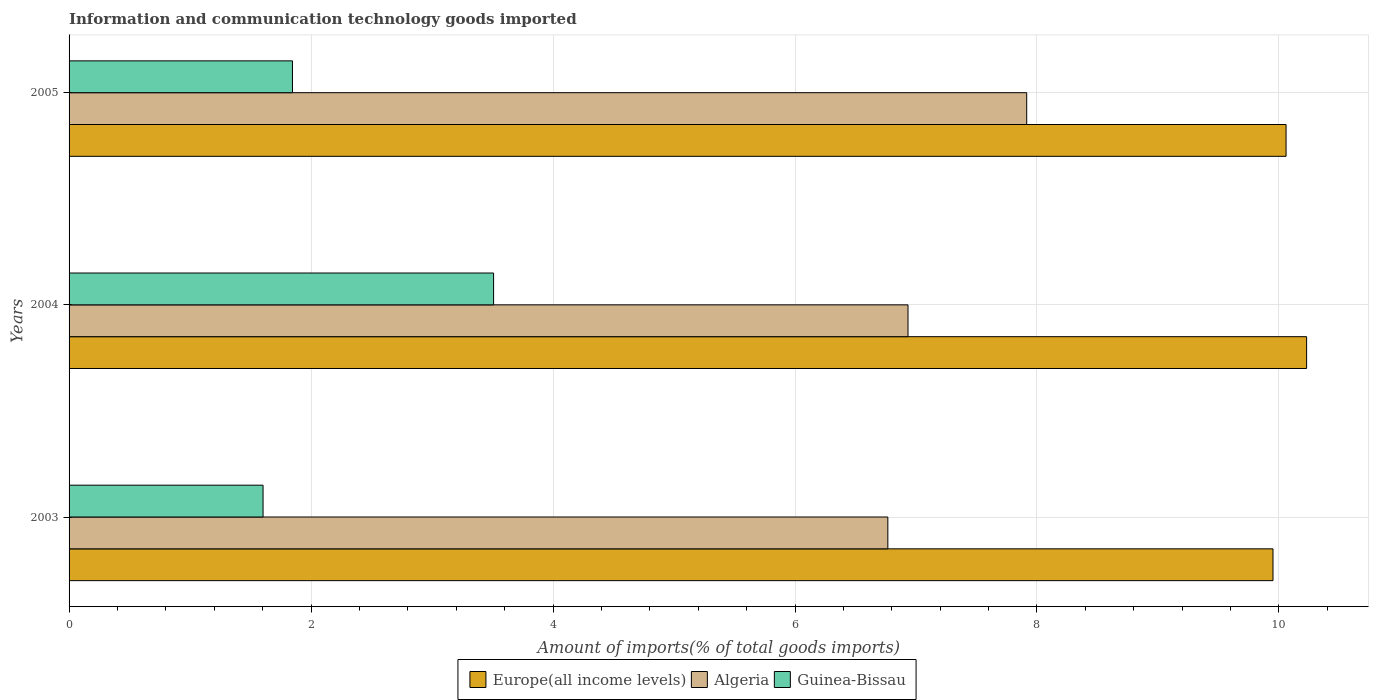How many different coloured bars are there?
Your answer should be very brief. 3. Are the number of bars per tick equal to the number of legend labels?
Your answer should be compact. Yes. In how many cases, is the number of bars for a given year not equal to the number of legend labels?
Your answer should be compact. 0. What is the amount of goods imported in Algeria in 2004?
Your response must be concise. 6.93. Across all years, what is the maximum amount of goods imported in Europe(all income levels)?
Keep it short and to the point. 10.23. Across all years, what is the minimum amount of goods imported in Algeria?
Your answer should be very brief. 6.77. In which year was the amount of goods imported in Europe(all income levels) maximum?
Provide a short and direct response. 2004. What is the total amount of goods imported in Guinea-Bissau in the graph?
Give a very brief answer. 6.96. What is the difference between the amount of goods imported in Algeria in 2004 and that in 2005?
Offer a terse response. -0.98. What is the difference between the amount of goods imported in Guinea-Bissau in 2005 and the amount of goods imported in Algeria in 2003?
Your answer should be compact. -4.92. What is the average amount of goods imported in Guinea-Bissau per year?
Keep it short and to the point. 2.32. In the year 2003, what is the difference between the amount of goods imported in Guinea-Bissau and amount of goods imported in Algeria?
Keep it short and to the point. -5.16. In how many years, is the amount of goods imported in Guinea-Bissau greater than 1.6 %?
Ensure brevity in your answer.  3. What is the ratio of the amount of goods imported in Guinea-Bissau in 2004 to that in 2005?
Your response must be concise. 1.9. What is the difference between the highest and the second highest amount of goods imported in Guinea-Bissau?
Ensure brevity in your answer.  1.66. What is the difference between the highest and the lowest amount of goods imported in Algeria?
Offer a very short reply. 1.15. In how many years, is the amount of goods imported in Guinea-Bissau greater than the average amount of goods imported in Guinea-Bissau taken over all years?
Your answer should be compact. 1. Is the sum of the amount of goods imported in Europe(all income levels) in 2003 and 2005 greater than the maximum amount of goods imported in Algeria across all years?
Your answer should be very brief. Yes. What does the 1st bar from the top in 2004 represents?
Make the answer very short. Guinea-Bissau. What does the 1st bar from the bottom in 2005 represents?
Your answer should be very brief. Europe(all income levels). Are the values on the major ticks of X-axis written in scientific E-notation?
Ensure brevity in your answer.  No. Does the graph contain grids?
Provide a short and direct response. Yes. Where does the legend appear in the graph?
Offer a very short reply. Bottom center. How many legend labels are there?
Your response must be concise. 3. What is the title of the graph?
Provide a succinct answer. Information and communication technology goods imported. What is the label or title of the X-axis?
Your response must be concise. Amount of imports(% of total goods imports). What is the label or title of the Y-axis?
Keep it short and to the point. Years. What is the Amount of imports(% of total goods imports) in Europe(all income levels) in 2003?
Your response must be concise. 9.95. What is the Amount of imports(% of total goods imports) of Algeria in 2003?
Provide a short and direct response. 6.77. What is the Amount of imports(% of total goods imports) of Guinea-Bissau in 2003?
Your answer should be very brief. 1.6. What is the Amount of imports(% of total goods imports) of Europe(all income levels) in 2004?
Offer a terse response. 10.23. What is the Amount of imports(% of total goods imports) in Algeria in 2004?
Ensure brevity in your answer.  6.93. What is the Amount of imports(% of total goods imports) of Guinea-Bissau in 2004?
Your response must be concise. 3.51. What is the Amount of imports(% of total goods imports) in Europe(all income levels) in 2005?
Keep it short and to the point. 10.06. What is the Amount of imports(% of total goods imports) in Algeria in 2005?
Your answer should be very brief. 7.92. What is the Amount of imports(% of total goods imports) in Guinea-Bissau in 2005?
Offer a very short reply. 1.85. Across all years, what is the maximum Amount of imports(% of total goods imports) of Europe(all income levels)?
Make the answer very short. 10.23. Across all years, what is the maximum Amount of imports(% of total goods imports) of Algeria?
Provide a short and direct response. 7.92. Across all years, what is the maximum Amount of imports(% of total goods imports) of Guinea-Bissau?
Offer a very short reply. 3.51. Across all years, what is the minimum Amount of imports(% of total goods imports) in Europe(all income levels)?
Give a very brief answer. 9.95. Across all years, what is the minimum Amount of imports(% of total goods imports) in Algeria?
Your response must be concise. 6.77. Across all years, what is the minimum Amount of imports(% of total goods imports) of Guinea-Bissau?
Provide a short and direct response. 1.6. What is the total Amount of imports(% of total goods imports) of Europe(all income levels) in the graph?
Your answer should be very brief. 30.24. What is the total Amount of imports(% of total goods imports) in Algeria in the graph?
Offer a terse response. 21.62. What is the total Amount of imports(% of total goods imports) of Guinea-Bissau in the graph?
Offer a very short reply. 6.96. What is the difference between the Amount of imports(% of total goods imports) of Europe(all income levels) in 2003 and that in 2004?
Provide a succinct answer. -0.28. What is the difference between the Amount of imports(% of total goods imports) of Algeria in 2003 and that in 2004?
Provide a succinct answer. -0.17. What is the difference between the Amount of imports(% of total goods imports) in Guinea-Bissau in 2003 and that in 2004?
Make the answer very short. -1.91. What is the difference between the Amount of imports(% of total goods imports) in Europe(all income levels) in 2003 and that in 2005?
Ensure brevity in your answer.  -0.11. What is the difference between the Amount of imports(% of total goods imports) in Algeria in 2003 and that in 2005?
Provide a succinct answer. -1.15. What is the difference between the Amount of imports(% of total goods imports) of Guinea-Bissau in 2003 and that in 2005?
Provide a short and direct response. -0.24. What is the difference between the Amount of imports(% of total goods imports) in Europe(all income levels) in 2004 and that in 2005?
Make the answer very short. 0.17. What is the difference between the Amount of imports(% of total goods imports) in Algeria in 2004 and that in 2005?
Make the answer very short. -0.98. What is the difference between the Amount of imports(% of total goods imports) of Guinea-Bissau in 2004 and that in 2005?
Offer a very short reply. 1.66. What is the difference between the Amount of imports(% of total goods imports) of Europe(all income levels) in 2003 and the Amount of imports(% of total goods imports) of Algeria in 2004?
Ensure brevity in your answer.  3.02. What is the difference between the Amount of imports(% of total goods imports) in Europe(all income levels) in 2003 and the Amount of imports(% of total goods imports) in Guinea-Bissau in 2004?
Offer a very short reply. 6.44. What is the difference between the Amount of imports(% of total goods imports) in Algeria in 2003 and the Amount of imports(% of total goods imports) in Guinea-Bissau in 2004?
Ensure brevity in your answer.  3.26. What is the difference between the Amount of imports(% of total goods imports) of Europe(all income levels) in 2003 and the Amount of imports(% of total goods imports) of Algeria in 2005?
Provide a succinct answer. 2.04. What is the difference between the Amount of imports(% of total goods imports) of Europe(all income levels) in 2003 and the Amount of imports(% of total goods imports) of Guinea-Bissau in 2005?
Offer a terse response. 8.1. What is the difference between the Amount of imports(% of total goods imports) of Algeria in 2003 and the Amount of imports(% of total goods imports) of Guinea-Bissau in 2005?
Your response must be concise. 4.92. What is the difference between the Amount of imports(% of total goods imports) in Europe(all income levels) in 2004 and the Amount of imports(% of total goods imports) in Algeria in 2005?
Make the answer very short. 2.31. What is the difference between the Amount of imports(% of total goods imports) in Europe(all income levels) in 2004 and the Amount of imports(% of total goods imports) in Guinea-Bissau in 2005?
Your answer should be very brief. 8.38. What is the difference between the Amount of imports(% of total goods imports) in Algeria in 2004 and the Amount of imports(% of total goods imports) in Guinea-Bissau in 2005?
Give a very brief answer. 5.09. What is the average Amount of imports(% of total goods imports) of Europe(all income levels) per year?
Your answer should be compact. 10.08. What is the average Amount of imports(% of total goods imports) of Algeria per year?
Make the answer very short. 7.21. What is the average Amount of imports(% of total goods imports) in Guinea-Bissau per year?
Provide a short and direct response. 2.32. In the year 2003, what is the difference between the Amount of imports(% of total goods imports) of Europe(all income levels) and Amount of imports(% of total goods imports) of Algeria?
Make the answer very short. 3.18. In the year 2003, what is the difference between the Amount of imports(% of total goods imports) in Europe(all income levels) and Amount of imports(% of total goods imports) in Guinea-Bissau?
Your answer should be very brief. 8.35. In the year 2003, what is the difference between the Amount of imports(% of total goods imports) of Algeria and Amount of imports(% of total goods imports) of Guinea-Bissau?
Give a very brief answer. 5.16. In the year 2004, what is the difference between the Amount of imports(% of total goods imports) in Europe(all income levels) and Amount of imports(% of total goods imports) in Algeria?
Make the answer very short. 3.29. In the year 2004, what is the difference between the Amount of imports(% of total goods imports) of Europe(all income levels) and Amount of imports(% of total goods imports) of Guinea-Bissau?
Provide a succinct answer. 6.72. In the year 2004, what is the difference between the Amount of imports(% of total goods imports) in Algeria and Amount of imports(% of total goods imports) in Guinea-Bissau?
Keep it short and to the point. 3.43. In the year 2005, what is the difference between the Amount of imports(% of total goods imports) of Europe(all income levels) and Amount of imports(% of total goods imports) of Algeria?
Give a very brief answer. 2.14. In the year 2005, what is the difference between the Amount of imports(% of total goods imports) of Europe(all income levels) and Amount of imports(% of total goods imports) of Guinea-Bissau?
Your response must be concise. 8.21. In the year 2005, what is the difference between the Amount of imports(% of total goods imports) in Algeria and Amount of imports(% of total goods imports) in Guinea-Bissau?
Offer a very short reply. 6.07. What is the ratio of the Amount of imports(% of total goods imports) in Europe(all income levels) in 2003 to that in 2004?
Ensure brevity in your answer.  0.97. What is the ratio of the Amount of imports(% of total goods imports) of Algeria in 2003 to that in 2004?
Give a very brief answer. 0.98. What is the ratio of the Amount of imports(% of total goods imports) in Guinea-Bissau in 2003 to that in 2004?
Offer a terse response. 0.46. What is the ratio of the Amount of imports(% of total goods imports) in Europe(all income levels) in 2003 to that in 2005?
Make the answer very short. 0.99. What is the ratio of the Amount of imports(% of total goods imports) in Algeria in 2003 to that in 2005?
Give a very brief answer. 0.85. What is the ratio of the Amount of imports(% of total goods imports) of Guinea-Bissau in 2003 to that in 2005?
Provide a short and direct response. 0.87. What is the ratio of the Amount of imports(% of total goods imports) in Europe(all income levels) in 2004 to that in 2005?
Give a very brief answer. 1.02. What is the ratio of the Amount of imports(% of total goods imports) in Algeria in 2004 to that in 2005?
Ensure brevity in your answer.  0.88. What is the ratio of the Amount of imports(% of total goods imports) of Guinea-Bissau in 2004 to that in 2005?
Make the answer very short. 1.9. What is the difference between the highest and the second highest Amount of imports(% of total goods imports) in Europe(all income levels)?
Provide a succinct answer. 0.17. What is the difference between the highest and the second highest Amount of imports(% of total goods imports) in Guinea-Bissau?
Your response must be concise. 1.66. What is the difference between the highest and the lowest Amount of imports(% of total goods imports) in Europe(all income levels)?
Your answer should be compact. 0.28. What is the difference between the highest and the lowest Amount of imports(% of total goods imports) of Algeria?
Your answer should be compact. 1.15. What is the difference between the highest and the lowest Amount of imports(% of total goods imports) of Guinea-Bissau?
Provide a succinct answer. 1.91. 